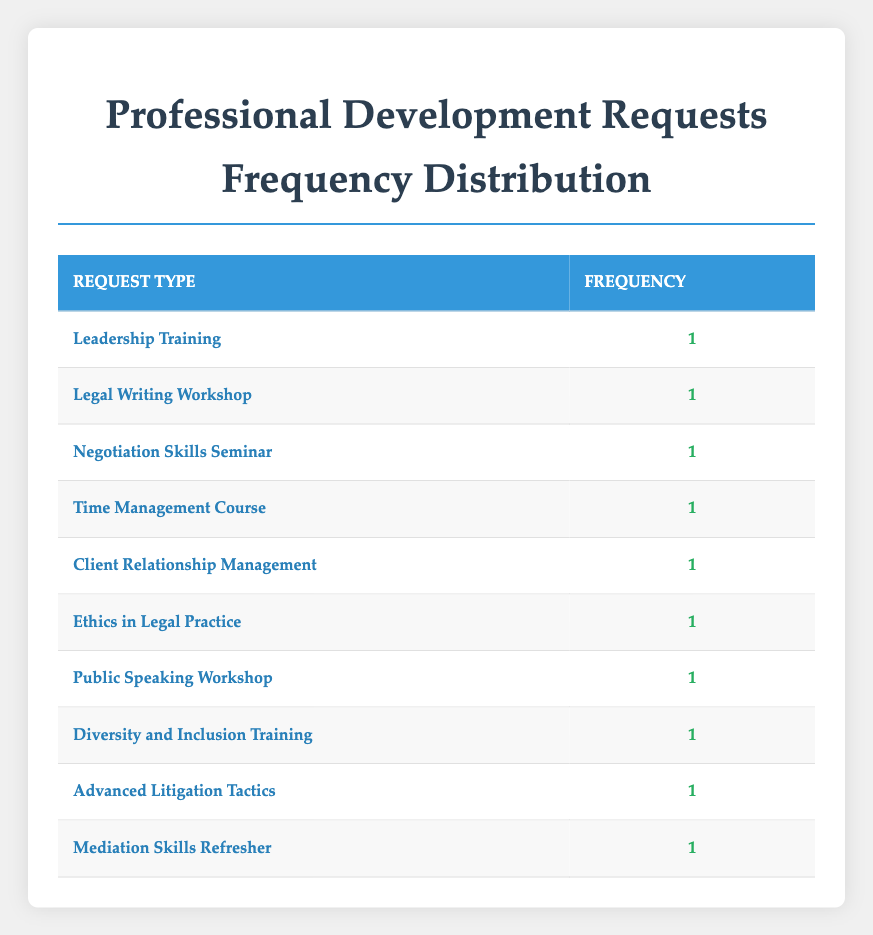What is the most requested type of professional development? Each request type in the table has a frequency of one, so there is no singular most requested type. All request types are equally requested.
Answer: All request types are equal How many associates requested training in time management? In the table, only one associate, Michael Brown, requested a Time Management Course.
Answer: 1 Is there a request for client relationship management training? Yes, Sarah Davis made a request for Client Relationship Management. This can be directly found in the table.
Answer: Yes Which training request has the latest date? The request for Mediation Skills Refresher by Brian Harris on April 12, 2023, is the latest date compared to other requests.
Answer: April 12, 2023 If we wanted to know the total number of professional development requests made by associates, what would that be? There are 10 unique entries in the table which represent individual professional development requests made by associates. Thus, the total number is 10.
Answer: 10 Are there any associates who requested both legal writing and negotiation skills training? Checking through the table reveals no associate has made more than one request, so there are no overlaps in requests.
Answer: No What types of training did more than one associate request? Reviewing the table shows that all request types were unique to one associate each; therefore, no types of training were requested by more than one associate.
Answer: None Which associate submitted a request for negotiation skills training? Emily Johnson is the associate who submitted a request for a Negotiation Skills Seminar, as seen directly in the table.
Answer: Emily Johnson What is the frequency of ethics in legal practice training requests? The table indicates that there is one request for Ethics in Legal Practice made by David Wilson.
Answer: 1 